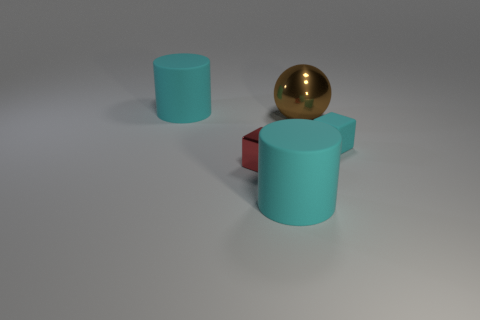Add 1 large brown metal things. How many objects exist? 6 Subtract all red cubes. How many cubes are left? 1 Subtract 1 blocks. How many blocks are left? 1 Subtract all tiny shiny things. Subtract all rubber objects. How many objects are left? 1 Add 1 brown spheres. How many brown spheres are left? 2 Add 5 small yellow cylinders. How many small yellow cylinders exist? 5 Subtract 0 brown cylinders. How many objects are left? 5 Subtract all cubes. How many objects are left? 3 Subtract all cyan cubes. Subtract all red cylinders. How many cubes are left? 1 